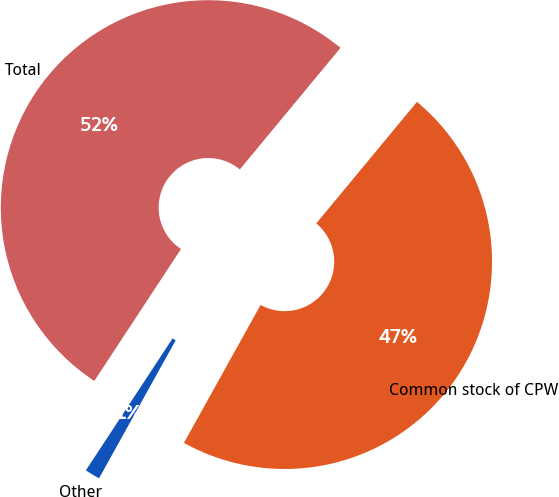Convert chart to OTSL. <chart><loc_0><loc_0><loc_500><loc_500><pie_chart><fcel>Common stock of CPW<fcel>Other<fcel>Total<nl><fcel>47.06%<fcel>1.18%<fcel>51.76%<nl></chart> 